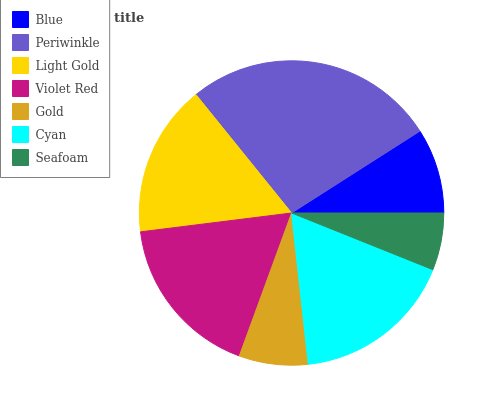Is Seafoam the minimum?
Answer yes or no. Yes. Is Periwinkle the maximum?
Answer yes or no. Yes. Is Light Gold the minimum?
Answer yes or no. No. Is Light Gold the maximum?
Answer yes or no. No. Is Periwinkle greater than Light Gold?
Answer yes or no. Yes. Is Light Gold less than Periwinkle?
Answer yes or no. Yes. Is Light Gold greater than Periwinkle?
Answer yes or no. No. Is Periwinkle less than Light Gold?
Answer yes or no. No. Is Light Gold the high median?
Answer yes or no. Yes. Is Light Gold the low median?
Answer yes or no. Yes. Is Cyan the high median?
Answer yes or no. No. Is Gold the low median?
Answer yes or no. No. 